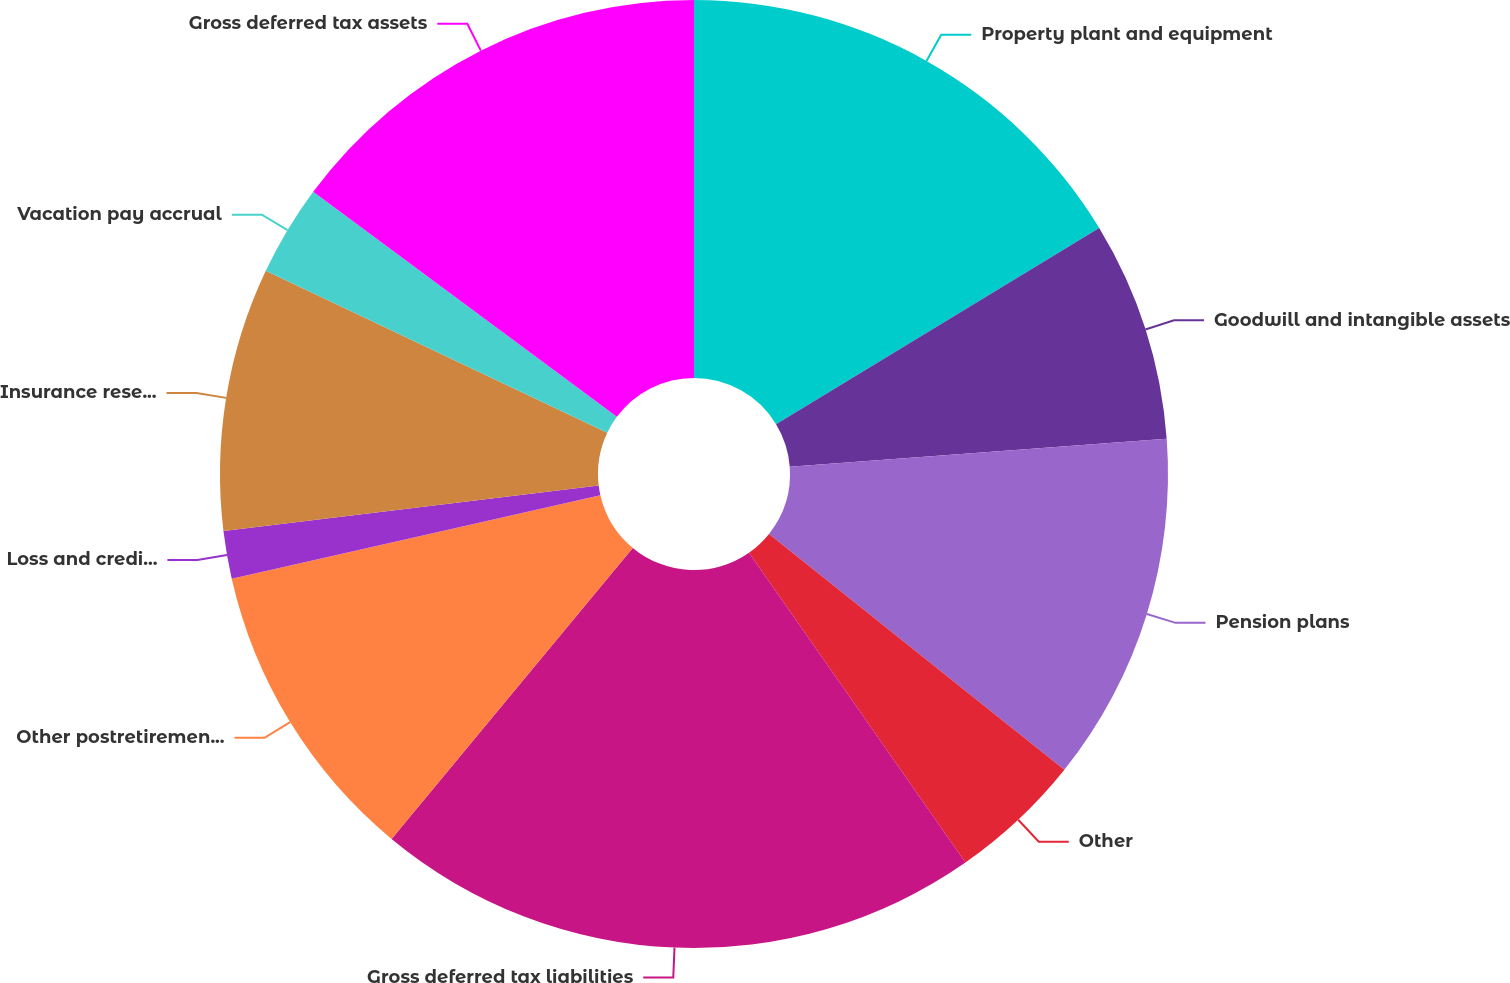Convert chart. <chart><loc_0><loc_0><loc_500><loc_500><pie_chart><fcel>Property plant and equipment<fcel>Goodwill and intangible assets<fcel>Pension plans<fcel>Other<fcel>Gross deferred tax liabilities<fcel>Other postretirement benefits<fcel>Loss and credit carryforwards<fcel>Insurance reserves<fcel>Vacation pay accrual<fcel>Gross deferred tax assets<nl><fcel>16.32%<fcel>7.5%<fcel>11.91%<fcel>4.57%<fcel>20.72%<fcel>10.44%<fcel>1.63%<fcel>8.97%<fcel>3.1%<fcel>14.85%<nl></chart> 